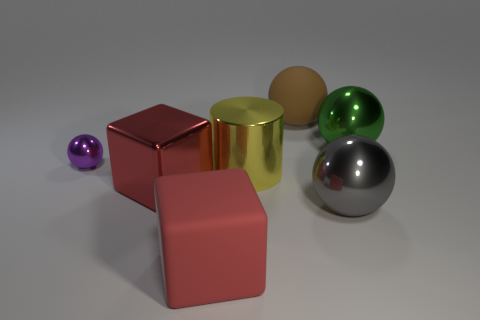Is there any other thing of the same color as the big rubber cube?
Offer a terse response. Yes. What is the color of the metallic cylinder that is the same size as the gray sphere?
Make the answer very short. Yellow. Are there the same number of large gray shiny objects behind the large gray metal object and big objects?
Give a very brief answer. No. There is a object that is both behind the big yellow shiny cylinder and left of the big matte ball; what is its shape?
Ensure brevity in your answer.  Sphere. Is the size of the purple ball the same as the red matte block?
Your answer should be very brief. No. Is there a red cube that has the same material as the tiny ball?
Give a very brief answer. Yes. There is a metal block that is the same color as the large rubber block; what size is it?
Offer a terse response. Large. How many shiny spheres are left of the green sphere and behind the large red metallic object?
Provide a succinct answer. 1. There is a purple object that is on the left side of the brown sphere; what is its material?
Offer a terse response. Metal. What number of other blocks have the same color as the rubber cube?
Your answer should be compact. 1. 